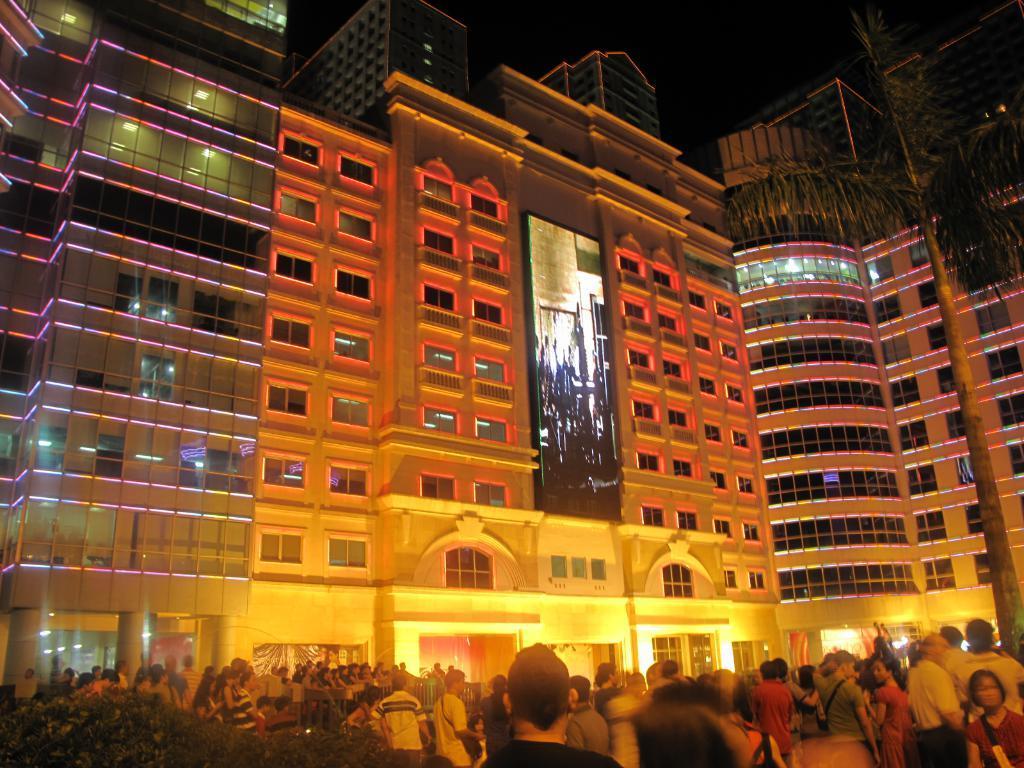How would you summarize this image in a sentence or two? In the foreground of the picture there are people and plants. In the center of the picture there are buildings, lights, screen and plants. Sky is dark. 